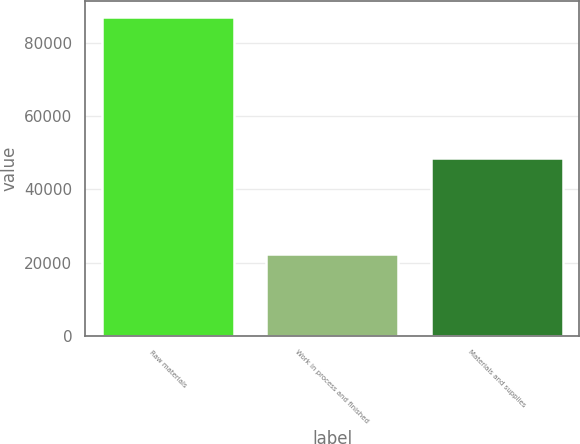Convert chart. <chart><loc_0><loc_0><loc_500><loc_500><bar_chart><fcel>Raw materials<fcel>Work in process and finished<fcel>Materials and supplies<nl><fcel>87159<fcel>22419<fcel>48655<nl></chart> 